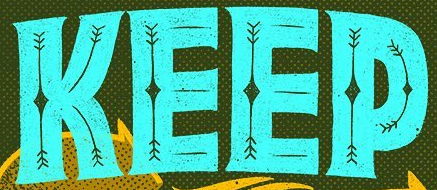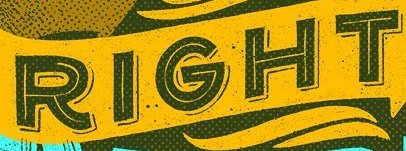Read the text content from these images in order, separated by a semicolon. KEEP; RIGHT 